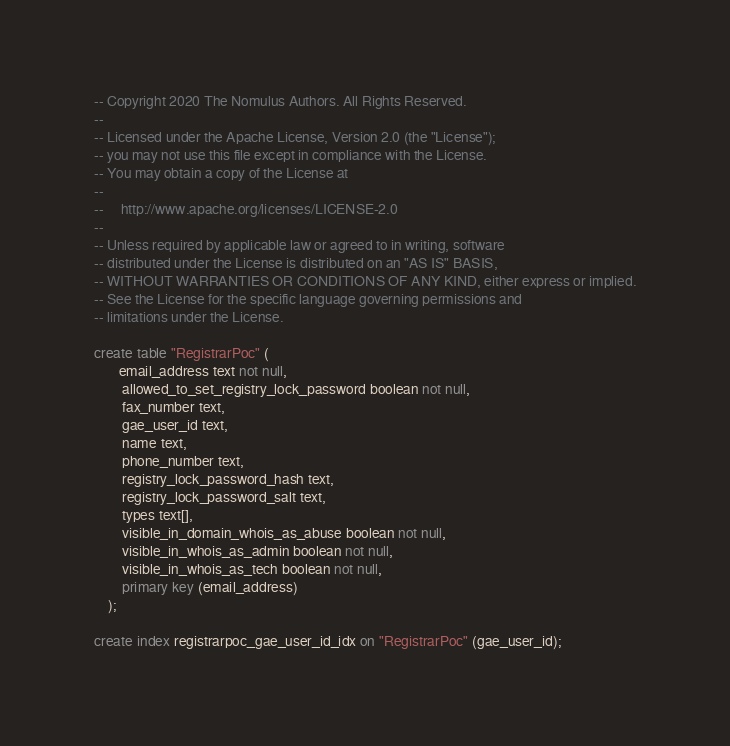<code> <loc_0><loc_0><loc_500><loc_500><_SQL_>-- Copyright 2020 The Nomulus Authors. All Rights Reserved.
--
-- Licensed under the Apache License, Version 2.0 (the "License");
-- you may not use this file except in compliance with the License.
-- You may obtain a copy of the License at
--
--     http://www.apache.org/licenses/LICENSE-2.0
--
-- Unless required by applicable law or agreed to in writing, software
-- distributed under the License is distributed on an "AS IS" BASIS,
-- WITHOUT WARRANTIES OR CONDITIONS OF ANY KIND, either express or implied.
-- See the License for the specific language governing permissions and
-- limitations under the License.

create table "RegistrarPoc" (
       email_address text not null,
        allowed_to_set_registry_lock_password boolean not null,
        fax_number text,
        gae_user_id text,
        name text,
        phone_number text,
        registry_lock_password_hash text,
        registry_lock_password_salt text,
        types text[],
        visible_in_domain_whois_as_abuse boolean not null,
        visible_in_whois_as_admin boolean not null,
        visible_in_whois_as_tech boolean not null,
        primary key (email_address)
    );

create index registrarpoc_gae_user_id_idx on "RegistrarPoc" (gae_user_id);
</code> 